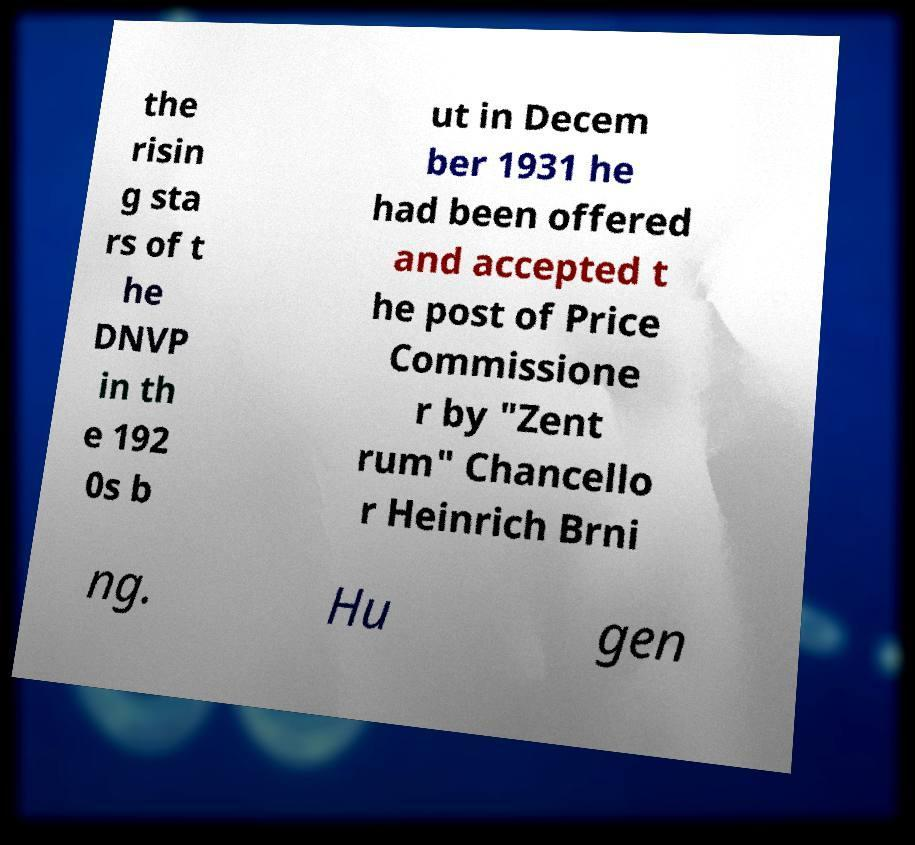Can you accurately transcribe the text from the provided image for me? the risin g sta rs of t he DNVP in th e 192 0s b ut in Decem ber 1931 he had been offered and accepted t he post of Price Commissione r by "Zent rum" Chancello r Heinrich Brni ng. Hu gen 